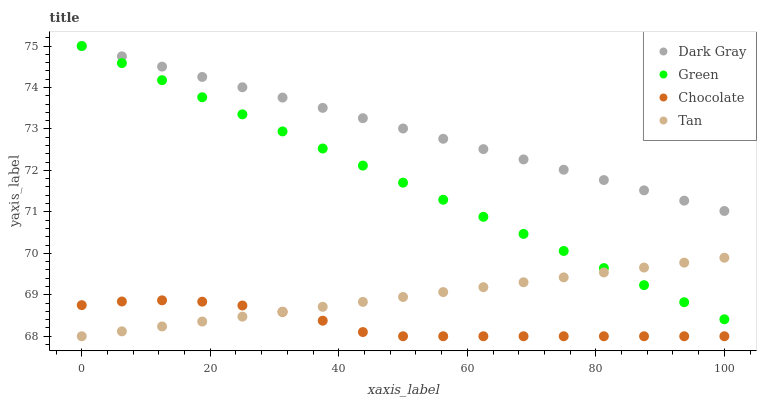Does Chocolate have the minimum area under the curve?
Answer yes or no. Yes. Does Dark Gray have the maximum area under the curve?
Answer yes or no. Yes. Does Tan have the minimum area under the curve?
Answer yes or no. No. Does Tan have the maximum area under the curve?
Answer yes or no. No. Is Green the smoothest?
Answer yes or no. Yes. Is Chocolate the roughest?
Answer yes or no. Yes. Is Tan the smoothest?
Answer yes or no. No. Is Tan the roughest?
Answer yes or no. No. Does Tan have the lowest value?
Answer yes or no. Yes. Does Green have the lowest value?
Answer yes or no. No. Does Green have the highest value?
Answer yes or no. Yes. Does Tan have the highest value?
Answer yes or no. No. Is Chocolate less than Green?
Answer yes or no. Yes. Is Dark Gray greater than Tan?
Answer yes or no. Yes. Does Tan intersect Green?
Answer yes or no. Yes. Is Tan less than Green?
Answer yes or no. No. Is Tan greater than Green?
Answer yes or no. No. Does Chocolate intersect Green?
Answer yes or no. No. 